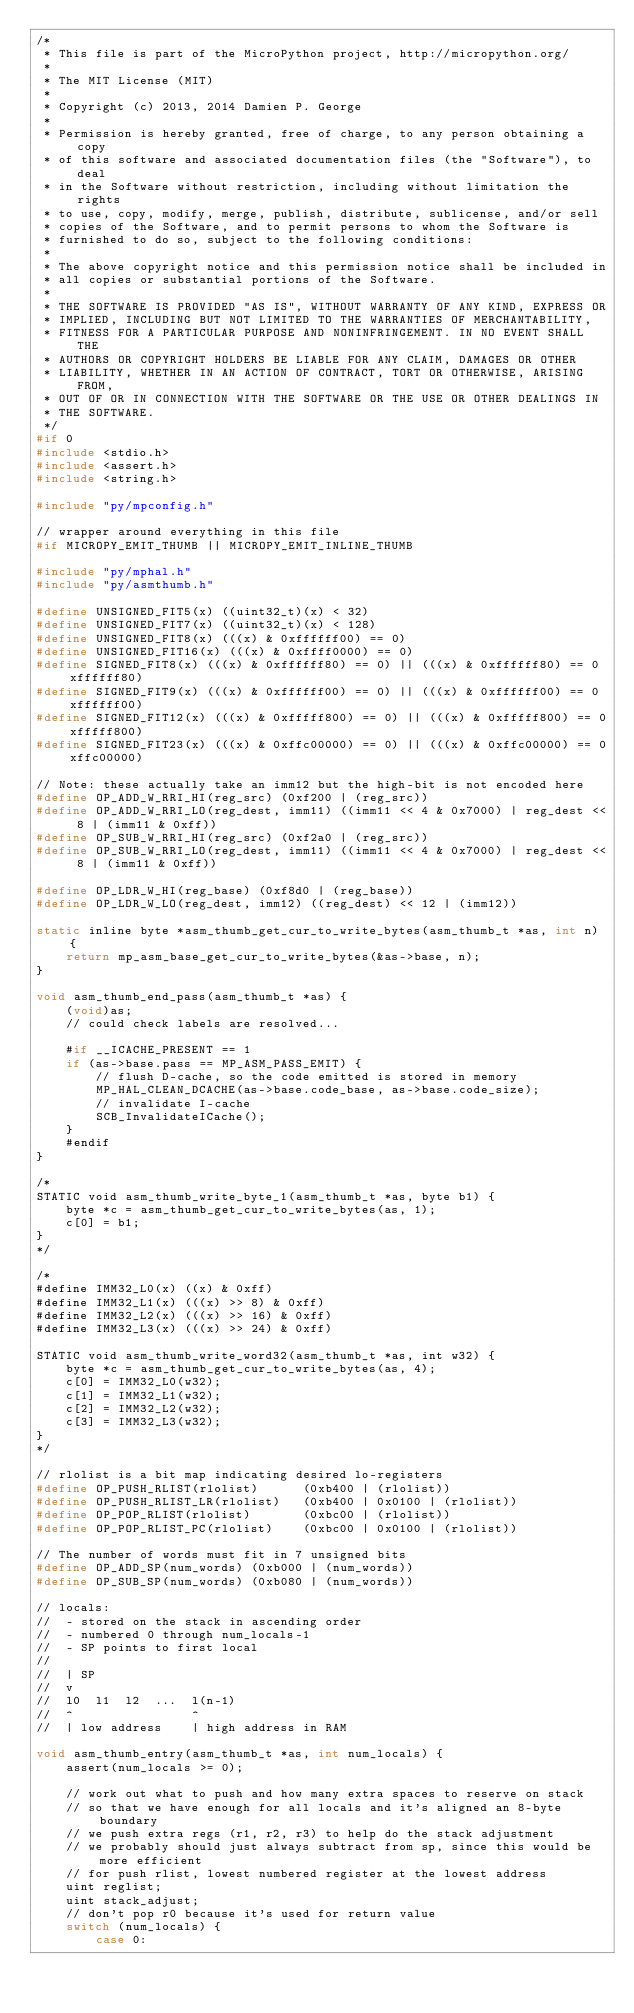Convert code to text. <code><loc_0><loc_0><loc_500><loc_500><_C_>/*
 * This file is part of the MicroPython project, http://micropython.org/
 *
 * The MIT License (MIT)
 *
 * Copyright (c) 2013, 2014 Damien P. George
 *
 * Permission is hereby granted, free of charge, to any person obtaining a copy
 * of this software and associated documentation files (the "Software"), to deal
 * in the Software without restriction, including without limitation the rights
 * to use, copy, modify, merge, publish, distribute, sublicense, and/or sell
 * copies of the Software, and to permit persons to whom the Software is
 * furnished to do so, subject to the following conditions:
 *
 * The above copyright notice and this permission notice shall be included in
 * all copies or substantial portions of the Software.
 *
 * THE SOFTWARE IS PROVIDED "AS IS", WITHOUT WARRANTY OF ANY KIND, EXPRESS OR
 * IMPLIED, INCLUDING BUT NOT LIMITED TO THE WARRANTIES OF MERCHANTABILITY,
 * FITNESS FOR A PARTICULAR PURPOSE AND NONINFRINGEMENT. IN NO EVENT SHALL THE
 * AUTHORS OR COPYRIGHT HOLDERS BE LIABLE FOR ANY CLAIM, DAMAGES OR OTHER
 * LIABILITY, WHETHER IN AN ACTION OF CONTRACT, TORT OR OTHERWISE, ARISING FROM,
 * OUT OF OR IN CONNECTION WITH THE SOFTWARE OR THE USE OR OTHER DEALINGS IN
 * THE SOFTWARE.
 */
#if 0
#include <stdio.h>
#include <assert.h>
#include <string.h>

#include "py/mpconfig.h"

// wrapper around everything in this file
#if MICROPY_EMIT_THUMB || MICROPY_EMIT_INLINE_THUMB

#include "py/mphal.h"
#include "py/asmthumb.h"

#define UNSIGNED_FIT5(x) ((uint32_t)(x) < 32)
#define UNSIGNED_FIT7(x) ((uint32_t)(x) < 128)
#define UNSIGNED_FIT8(x) (((x) & 0xffffff00) == 0)
#define UNSIGNED_FIT16(x) (((x) & 0xffff0000) == 0)
#define SIGNED_FIT8(x) (((x) & 0xffffff80) == 0) || (((x) & 0xffffff80) == 0xffffff80)
#define SIGNED_FIT9(x) (((x) & 0xffffff00) == 0) || (((x) & 0xffffff00) == 0xffffff00)
#define SIGNED_FIT12(x) (((x) & 0xfffff800) == 0) || (((x) & 0xfffff800) == 0xfffff800)
#define SIGNED_FIT23(x) (((x) & 0xffc00000) == 0) || (((x) & 0xffc00000) == 0xffc00000)

// Note: these actually take an imm12 but the high-bit is not encoded here
#define OP_ADD_W_RRI_HI(reg_src) (0xf200 | (reg_src))
#define OP_ADD_W_RRI_LO(reg_dest, imm11) ((imm11 << 4 & 0x7000) | reg_dest << 8 | (imm11 & 0xff))
#define OP_SUB_W_RRI_HI(reg_src) (0xf2a0 | (reg_src))
#define OP_SUB_W_RRI_LO(reg_dest, imm11) ((imm11 << 4 & 0x7000) | reg_dest << 8 | (imm11 & 0xff))

#define OP_LDR_W_HI(reg_base) (0xf8d0 | (reg_base))
#define OP_LDR_W_LO(reg_dest, imm12) ((reg_dest) << 12 | (imm12))

static inline byte *asm_thumb_get_cur_to_write_bytes(asm_thumb_t *as, int n) {
    return mp_asm_base_get_cur_to_write_bytes(&as->base, n);
}

void asm_thumb_end_pass(asm_thumb_t *as) {
    (void)as;
    // could check labels are resolved...

    #if __ICACHE_PRESENT == 1
    if (as->base.pass == MP_ASM_PASS_EMIT) {
        // flush D-cache, so the code emitted is stored in memory
        MP_HAL_CLEAN_DCACHE(as->base.code_base, as->base.code_size);
        // invalidate I-cache
        SCB_InvalidateICache();
    }
    #endif
}

/*
STATIC void asm_thumb_write_byte_1(asm_thumb_t *as, byte b1) {
    byte *c = asm_thumb_get_cur_to_write_bytes(as, 1);
    c[0] = b1;
}
*/

/*
#define IMM32_L0(x) ((x) & 0xff)
#define IMM32_L1(x) (((x) >> 8) & 0xff)
#define IMM32_L2(x) (((x) >> 16) & 0xff)
#define IMM32_L3(x) (((x) >> 24) & 0xff)

STATIC void asm_thumb_write_word32(asm_thumb_t *as, int w32) {
    byte *c = asm_thumb_get_cur_to_write_bytes(as, 4);
    c[0] = IMM32_L0(w32);
    c[1] = IMM32_L1(w32);
    c[2] = IMM32_L2(w32);
    c[3] = IMM32_L3(w32);
}
*/

// rlolist is a bit map indicating desired lo-registers
#define OP_PUSH_RLIST(rlolist)      (0xb400 | (rlolist))
#define OP_PUSH_RLIST_LR(rlolist)   (0xb400 | 0x0100 | (rlolist))
#define OP_POP_RLIST(rlolist)       (0xbc00 | (rlolist))
#define OP_POP_RLIST_PC(rlolist)    (0xbc00 | 0x0100 | (rlolist))

// The number of words must fit in 7 unsigned bits
#define OP_ADD_SP(num_words) (0xb000 | (num_words))
#define OP_SUB_SP(num_words) (0xb080 | (num_words))

// locals:
//  - stored on the stack in ascending order
//  - numbered 0 through num_locals-1
//  - SP points to first local
//
//  | SP
//  v
//  l0  l1  l2  ...  l(n-1)
//  ^                ^
//  | low address    | high address in RAM

void asm_thumb_entry(asm_thumb_t *as, int num_locals) {
    assert(num_locals >= 0);

    // work out what to push and how many extra spaces to reserve on stack
    // so that we have enough for all locals and it's aligned an 8-byte boundary
    // we push extra regs (r1, r2, r3) to help do the stack adjustment
    // we probably should just always subtract from sp, since this would be more efficient
    // for push rlist, lowest numbered register at the lowest address
    uint reglist;
    uint stack_adjust;
    // don't pop r0 because it's used for return value
    switch (num_locals) {
        case 0:</code> 